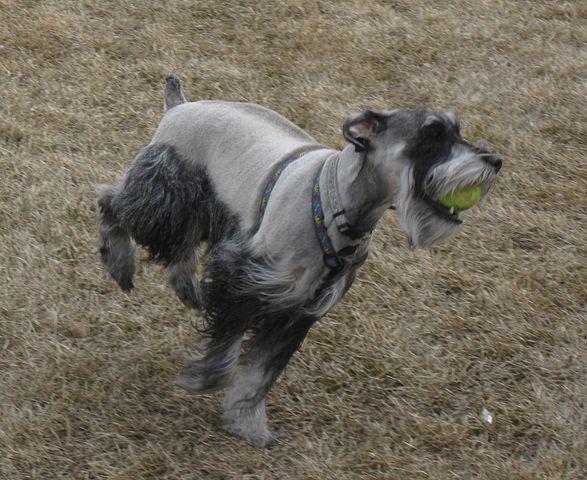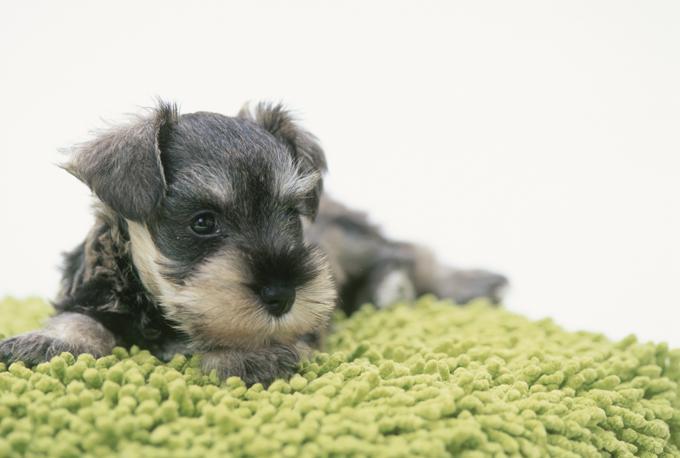The first image is the image on the left, the second image is the image on the right. Analyze the images presented: Is the assertion "An image shows a dog with its mouth on some type of chew bone." valid? Answer yes or no. No. The first image is the image on the left, the second image is the image on the right. Examine the images to the left and right. Is the description "The animal on the right is lying on a green colored surface." accurate? Answer yes or no. Yes. 